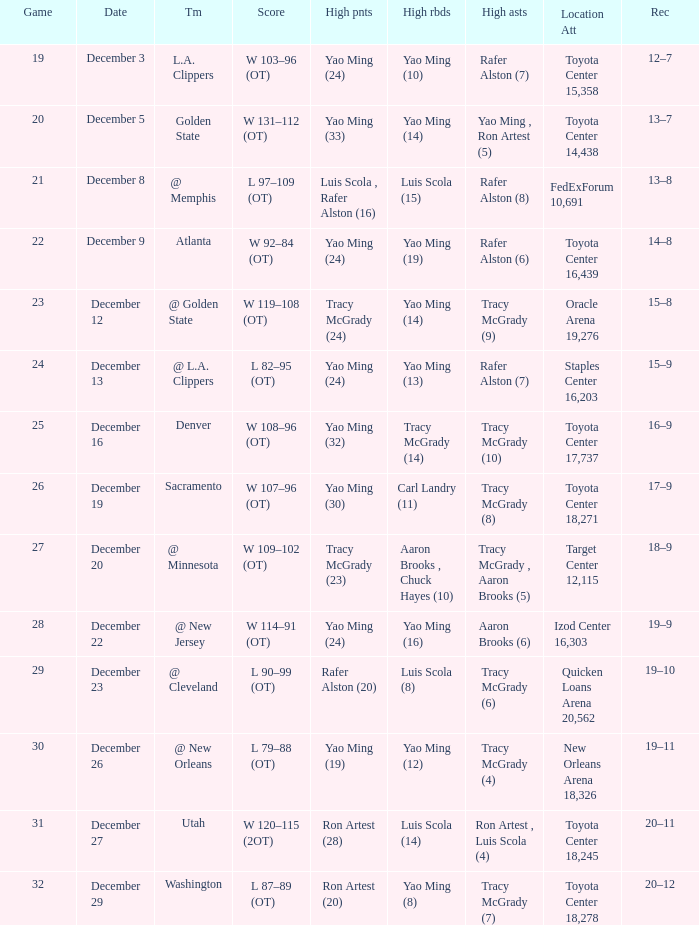When @ new orleans is the team who has the highest amount of rebounds? Yao Ming (12). 